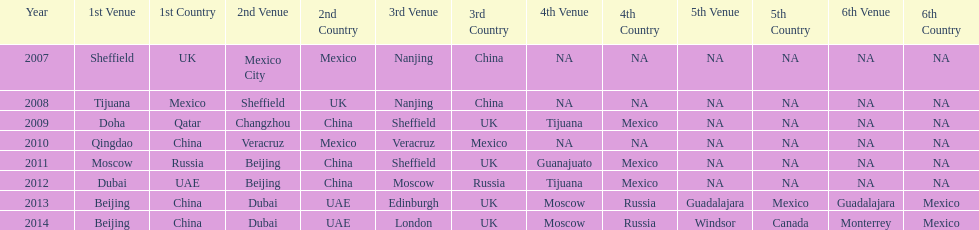How long, in years, has the this world series been occurring? 7 years. 